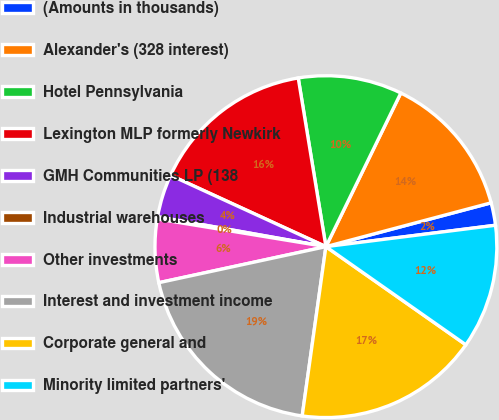Convert chart to OTSL. <chart><loc_0><loc_0><loc_500><loc_500><pie_chart><fcel>(Amounts in thousands)<fcel>Alexander's (328 interest)<fcel>Hotel Pennsylvania<fcel>Lexington MLP formerly Newkirk<fcel>GMH Communities LP (138<fcel>Industrial warehouses<fcel>Other investments<fcel>Interest and investment income<fcel>Corporate general and<fcel>Minority limited partners'<nl><fcel>2.13%<fcel>13.65%<fcel>9.81%<fcel>15.56%<fcel>4.05%<fcel>0.21%<fcel>5.97%<fcel>19.4%<fcel>17.48%<fcel>11.73%<nl></chart> 